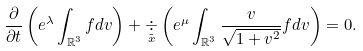Convert formula to latex. <formula><loc_0><loc_0><loc_500><loc_500>\frac { \partial } { \partial t } \left ( e ^ { \lambda } \int _ { \mathbb { R } ^ { 3 } } f d v \right ) + \underset { \tilde { x } } { \div } \left ( e ^ { \mu } \int _ { \mathbb { R } ^ { 3 } } \frac { v } { \sqrt { 1 + v ^ { 2 } } } f d v \right ) = 0 .</formula> 